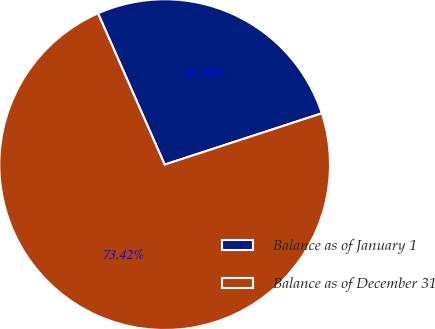Convert chart. <chart><loc_0><loc_0><loc_500><loc_500><pie_chart><fcel>Balance as of January 1<fcel>Balance as of December 31<nl><fcel>26.58%<fcel>73.42%<nl></chart> 